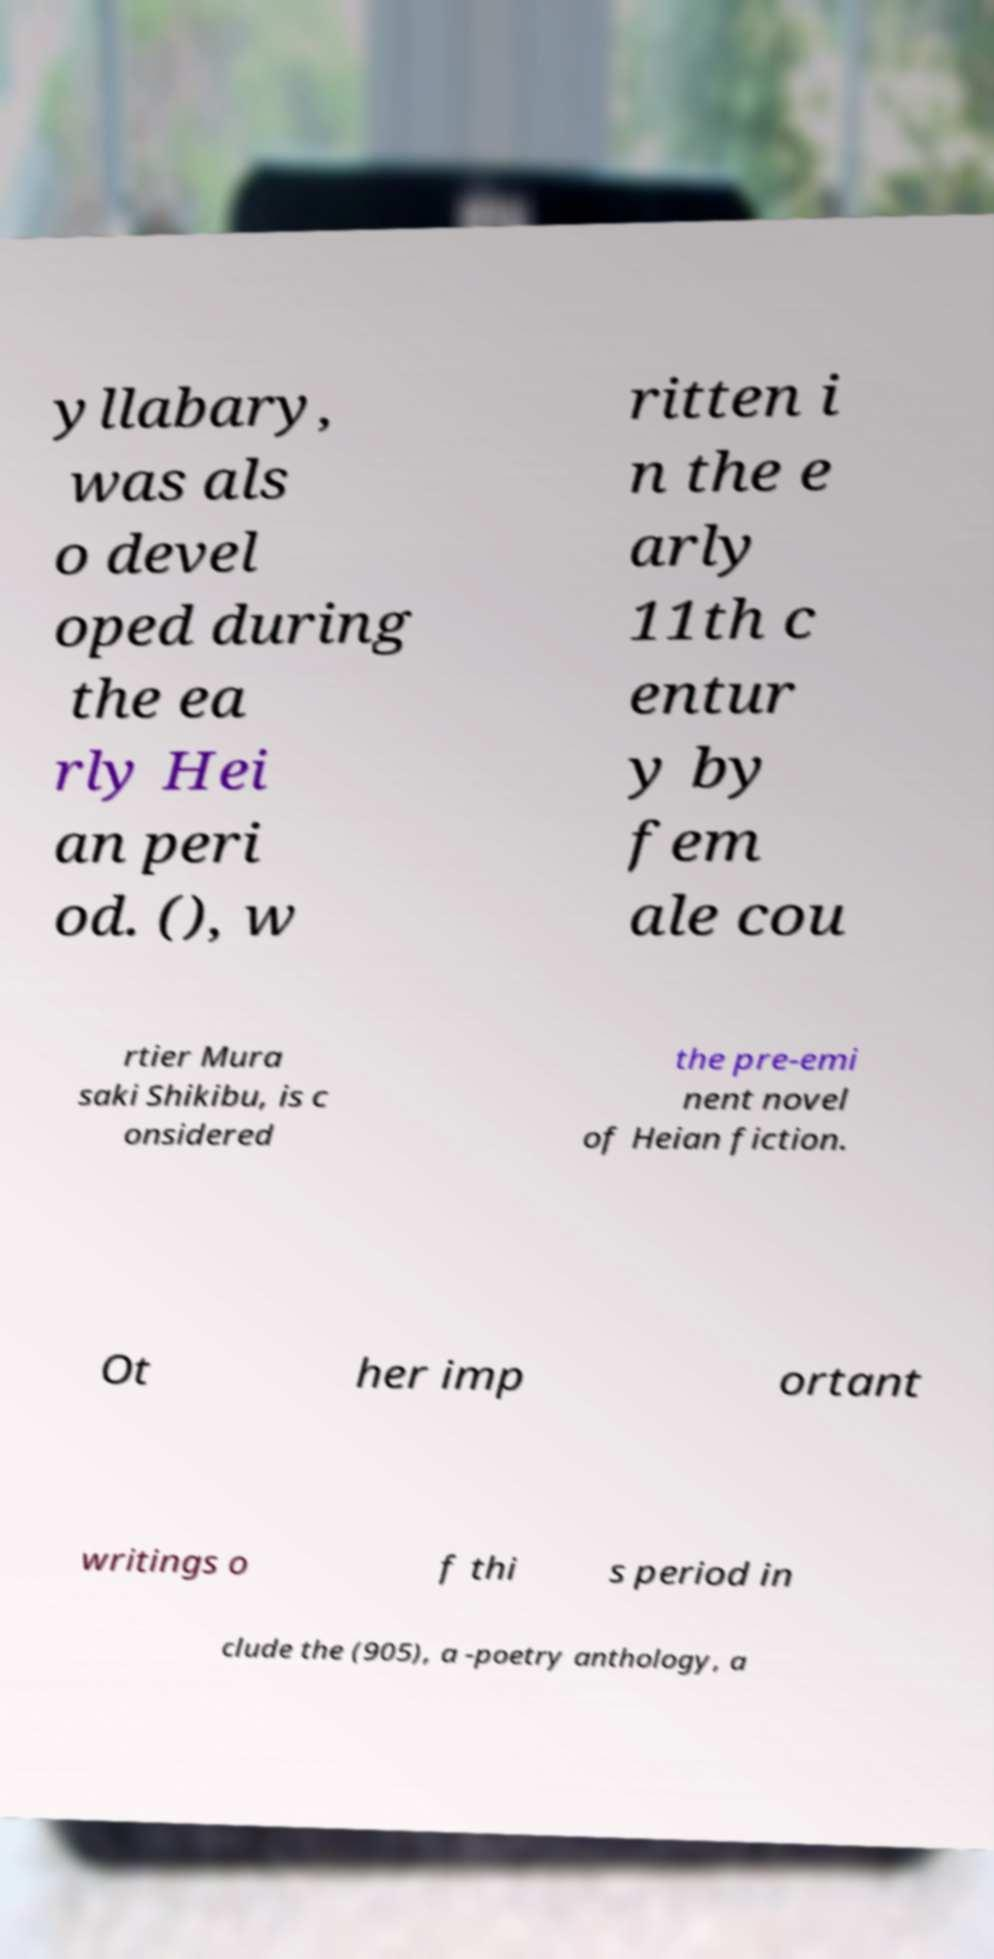For documentation purposes, I need the text within this image transcribed. Could you provide that? yllabary, was als o devel oped during the ea rly Hei an peri od. (), w ritten i n the e arly 11th c entur y by fem ale cou rtier Mura saki Shikibu, is c onsidered the pre-emi nent novel of Heian fiction. Ot her imp ortant writings o f thi s period in clude the (905), a -poetry anthology, a 